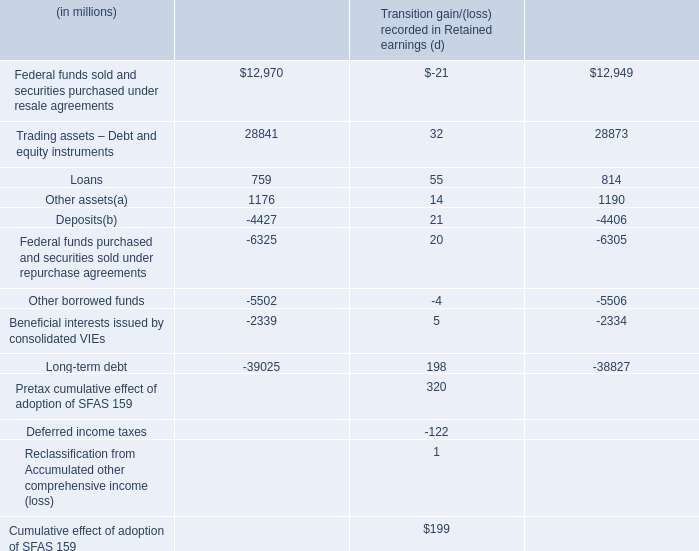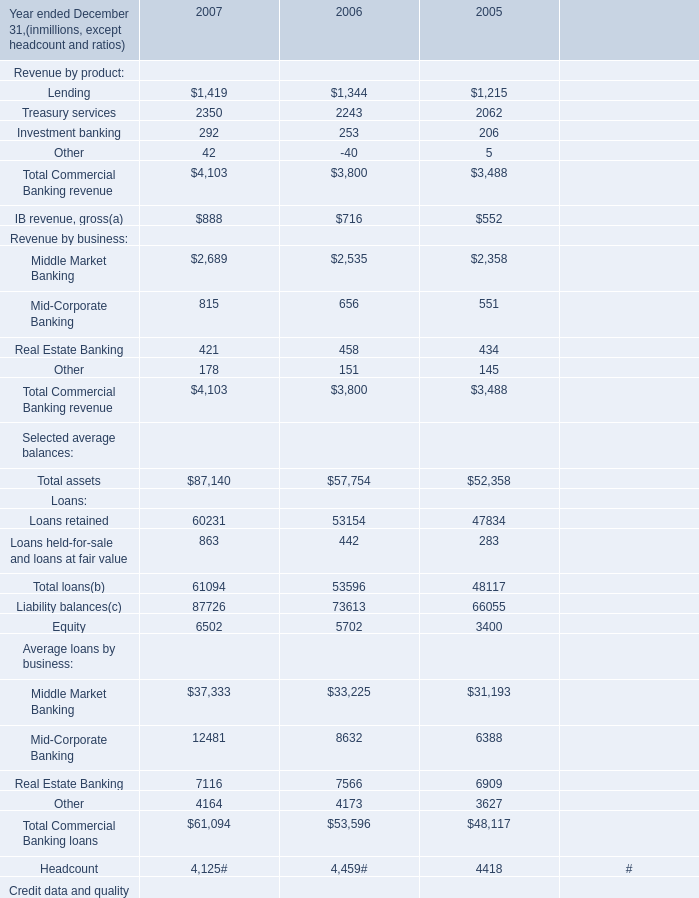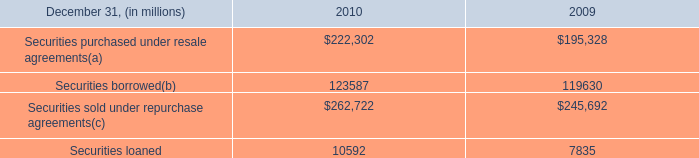What is the growing rate of Total assets in the year with the most Total Commercial Banking revenue? 
Computations: ((87140 - 57754) / 57754)
Answer: 0.50881. 